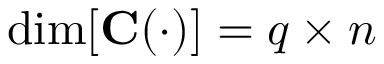Convert formula to latex. <formula><loc_0><loc_0><loc_500><loc_500>\dim [ C ( \cdot ) ] = q \times n</formula> 